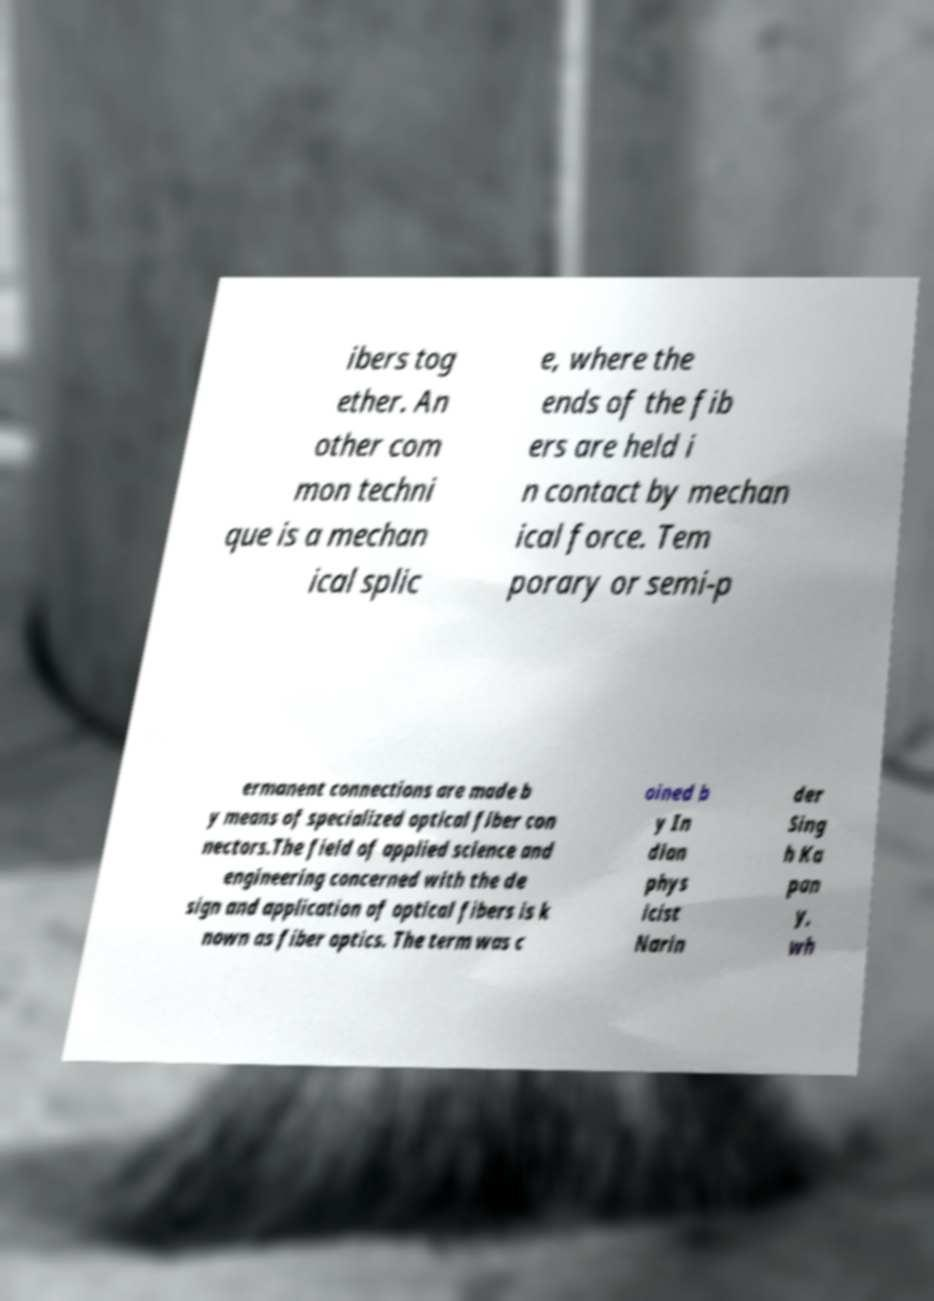Could you extract and type out the text from this image? ibers tog ether. An other com mon techni que is a mechan ical splic e, where the ends of the fib ers are held i n contact by mechan ical force. Tem porary or semi-p ermanent connections are made b y means of specialized optical fiber con nectors.The field of applied science and engineering concerned with the de sign and application of optical fibers is k nown as fiber optics. The term was c oined b y In dian phys icist Narin der Sing h Ka pan y, wh 